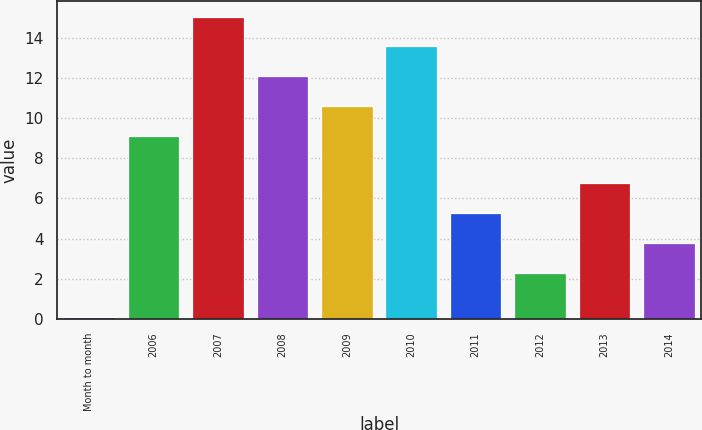<chart> <loc_0><loc_0><loc_500><loc_500><bar_chart><fcel>Month to month<fcel>2006<fcel>2007<fcel>2008<fcel>2009<fcel>2010<fcel>2011<fcel>2012<fcel>2013<fcel>2014<nl><fcel>0.1<fcel>9.1<fcel>15.06<fcel>12.08<fcel>10.59<fcel>13.57<fcel>5.28<fcel>2.3<fcel>6.77<fcel>3.79<nl></chart> 